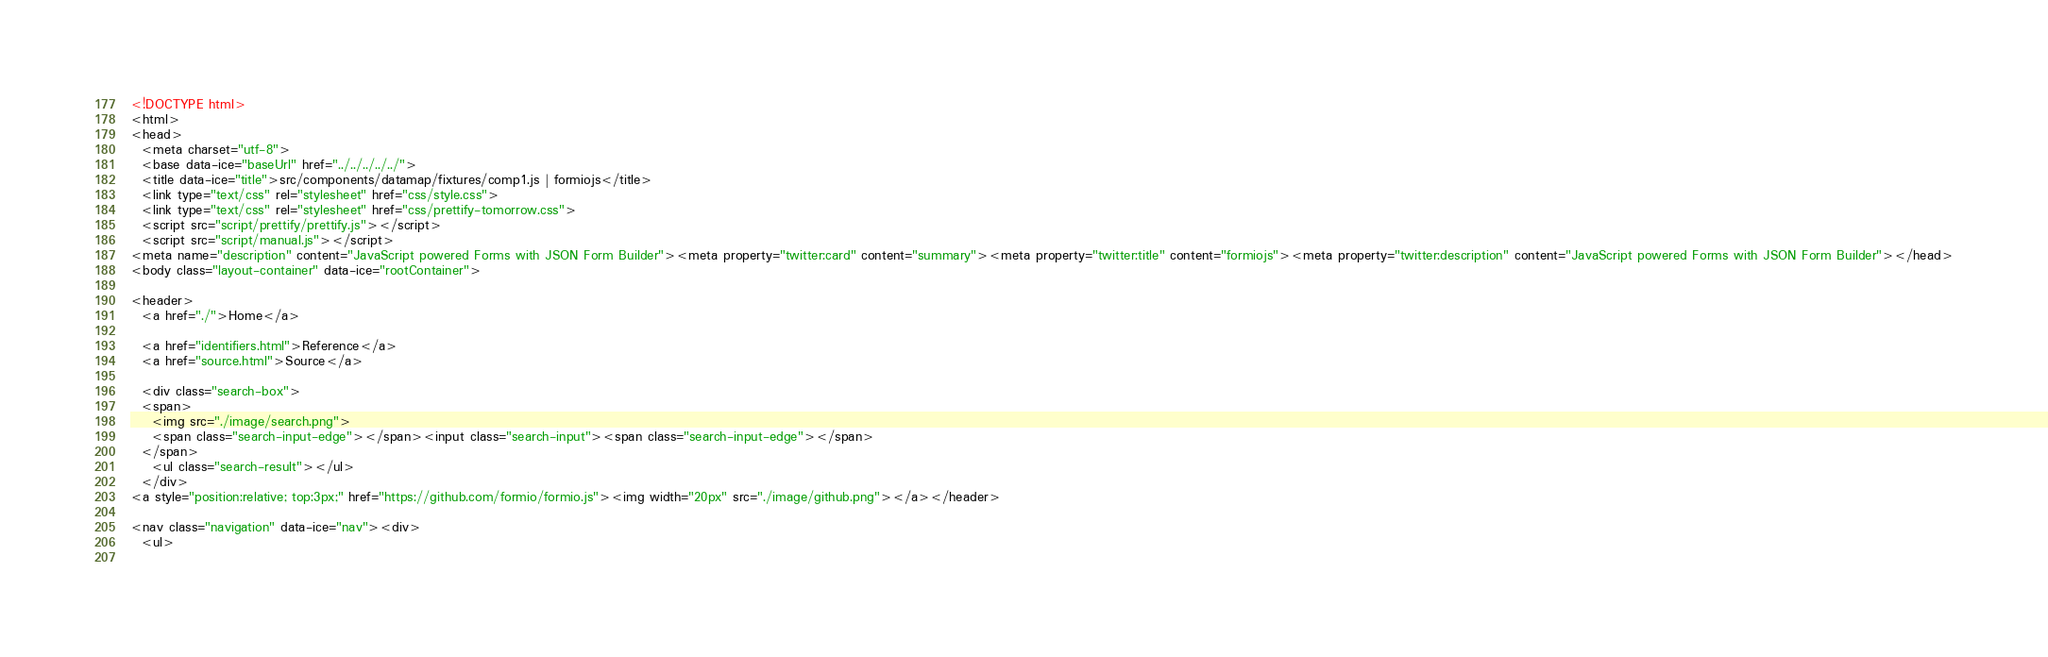Convert code to text. <code><loc_0><loc_0><loc_500><loc_500><_HTML_><!DOCTYPE html>
<html>
<head>
  <meta charset="utf-8">
  <base data-ice="baseUrl" href="../../../../../">
  <title data-ice="title">src/components/datamap/fixtures/comp1.js | formiojs</title>
  <link type="text/css" rel="stylesheet" href="css/style.css">
  <link type="text/css" rel="stylesheet" href="css/prettify-tomorrow.css">
  <script src="script/prettify/prettify.js"></script>
  <script src="script/manual.js"></script>
<meta name="description" content="JavaScript powered Forms with JSON Form Builder"><meta property="twitter:card" content="summary"><meta property="twitter:title" content="formiojs"><meta property="twitter:description" content="JavaScript powered Forms with JSON Form Builder"></head>
<body class="layout-container" data-ice="rootContainer">

<header>
  <a href="./">Home</a>
  
  <a href="identifiers.html">Reference</a>
  <a href="source.html">Source</a>
  
  <div class="search-box">
  <span>
    <img src="./image/search.png">
    <span class="search-input-edge"></span><input class="search-input"><span class="search-input-edge"></span>
  </span>
    <ul class="search-result"></ul>
  </div>
<a style="position:relative; top:3px;" href="https://github.com/formio/formio.js"><img width="20px" src="./image/github.png"></a></header>

<nav class="navigation" data-ice="nav"><div>
  <ul>
    </code> 